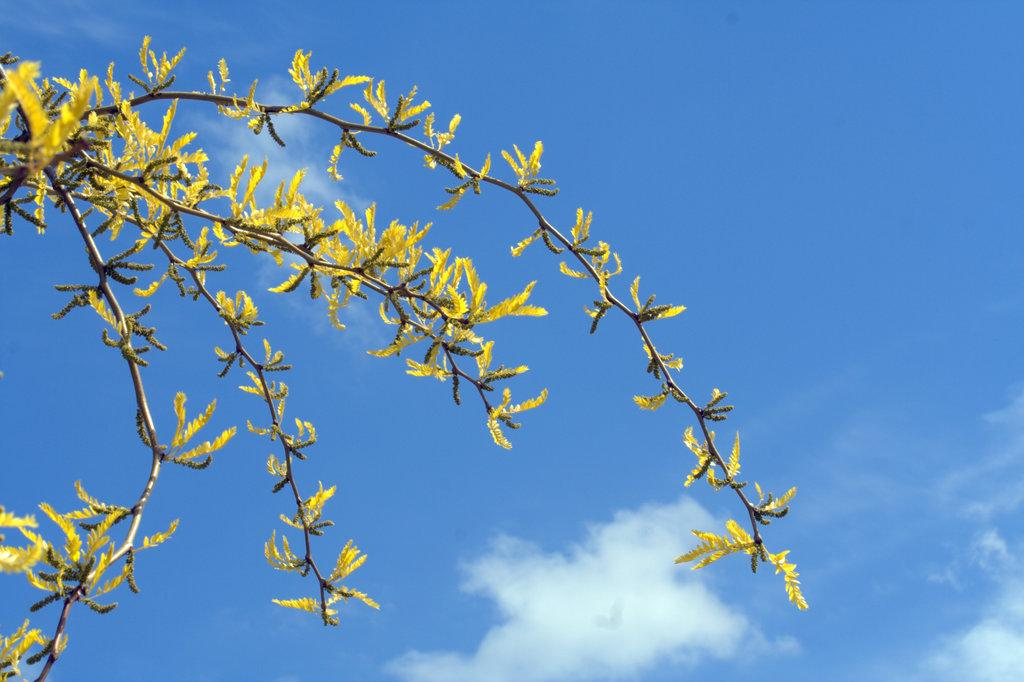What type of vegetation can be seen in the image? There is a tree in the image. What is visible in the background of the image? The sky is visible in the background of the image. What color of paint is being used on the eggs in the image? There are no eggs or paint present in the image. 